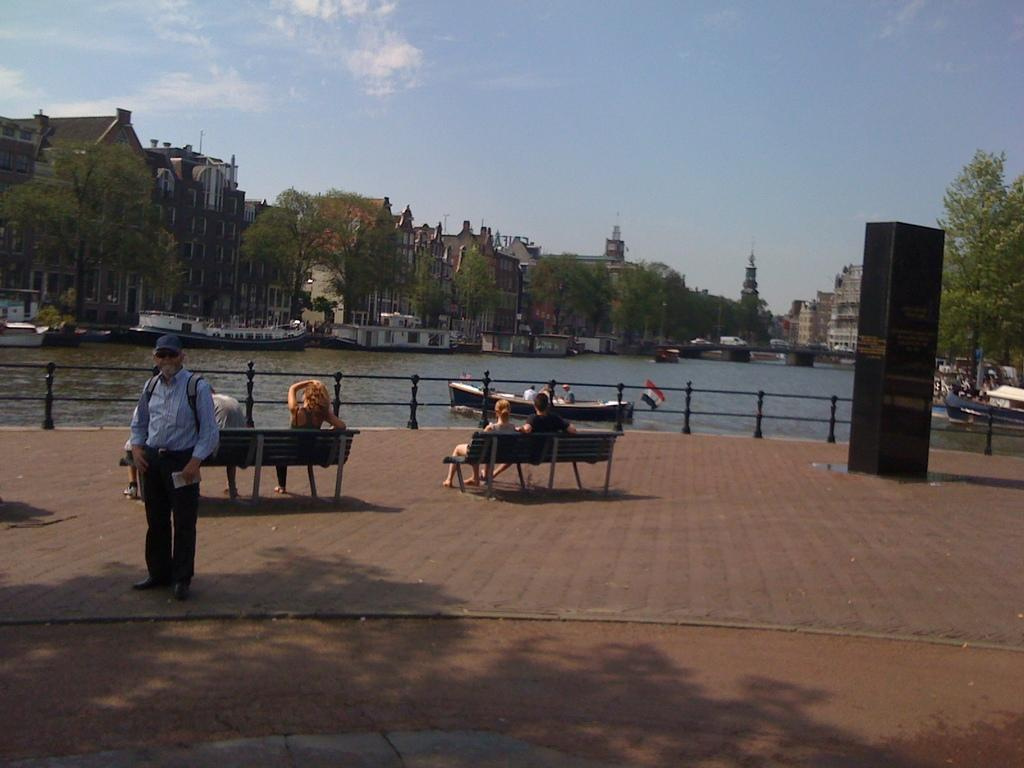What is the main subject of the image? There is a man standing in the image. What are the other people in the image doing? There are people sitting on benches in the image. What can be seen in the background of the image? There is a lake, buildings, and trees in the background of the image. What is the condition of the sky in the image? The sky is clear in the image. Can you tell me how many holes are visible in the image? There are no holes visible in the image. Who is the friend of the man standing in the image? There is no specific friend mentioned or depicted in the image. 